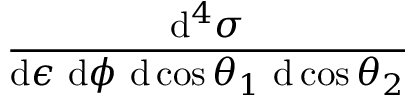Convert formula to latex. <formula><loc_0><loc_0><loc_500><loc_500>\frac { d ^ { 4 } \sigma } { d \epsilon \ d \phi \ d \cos \theta _ { 1 } \ d \cos \theta _ { 2 } }</formula> 